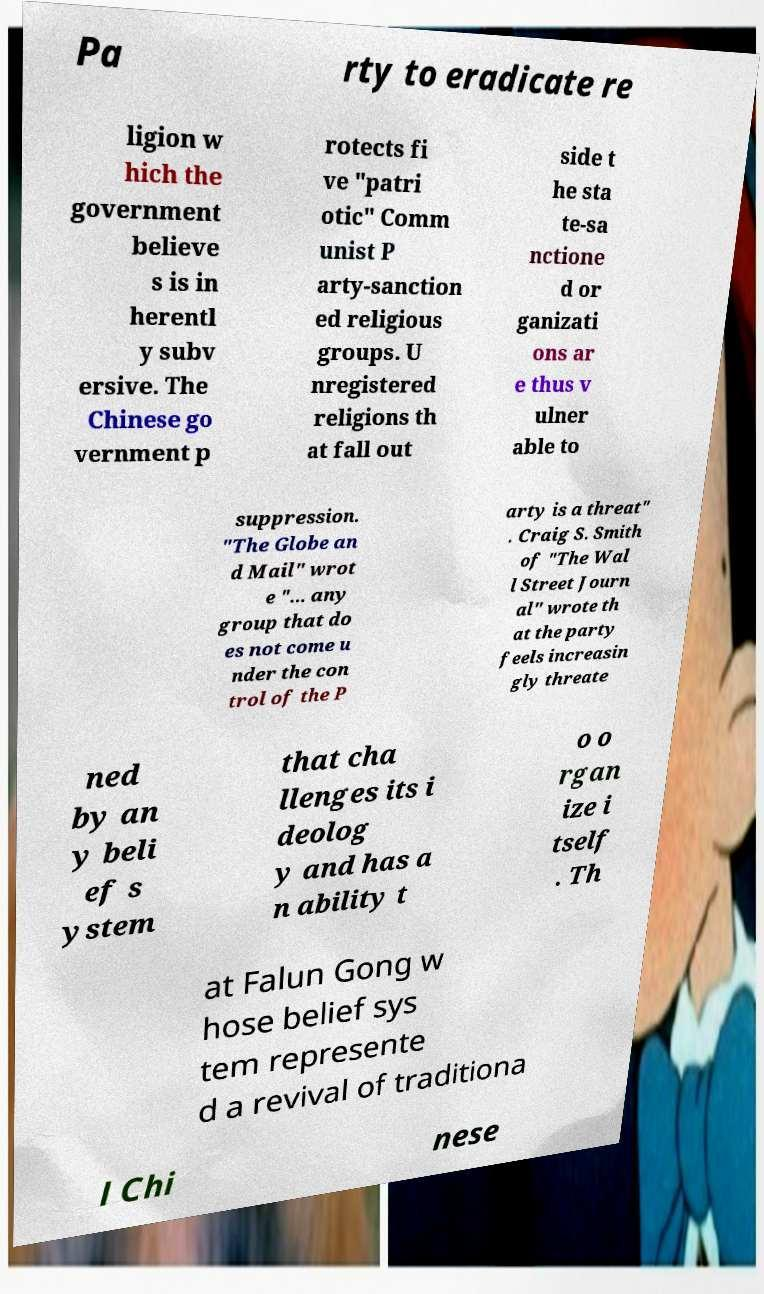Can you accurately transcribe the text from the provided image for me? Pa rty to eradicate re ligion w hich the government believe s is in herentl y subv ersive. The Chinese go vernment p rotects fi ve "patri otic" Comm unist P arty-sanction ed religious groups. U nregistered religions th at fall out side t he sta te-sa nctione d or ganizati ons ar e thus v ulner able to suppression. "The Globe an d Mail" wrot e "... any group that do es not come u nder the con trol of the P arty is a threat" . Craig S. Smith of "The Wal l Street Journ al" wrote th at the party feels increasin gly threate ned by an y beli ef s ystem that cha llenges its i deolog y and has a n ability t o o rgan ize i tself . Th at Falun Gong w hose belief sys tem represente d a revival of traditiona l Chi nese 